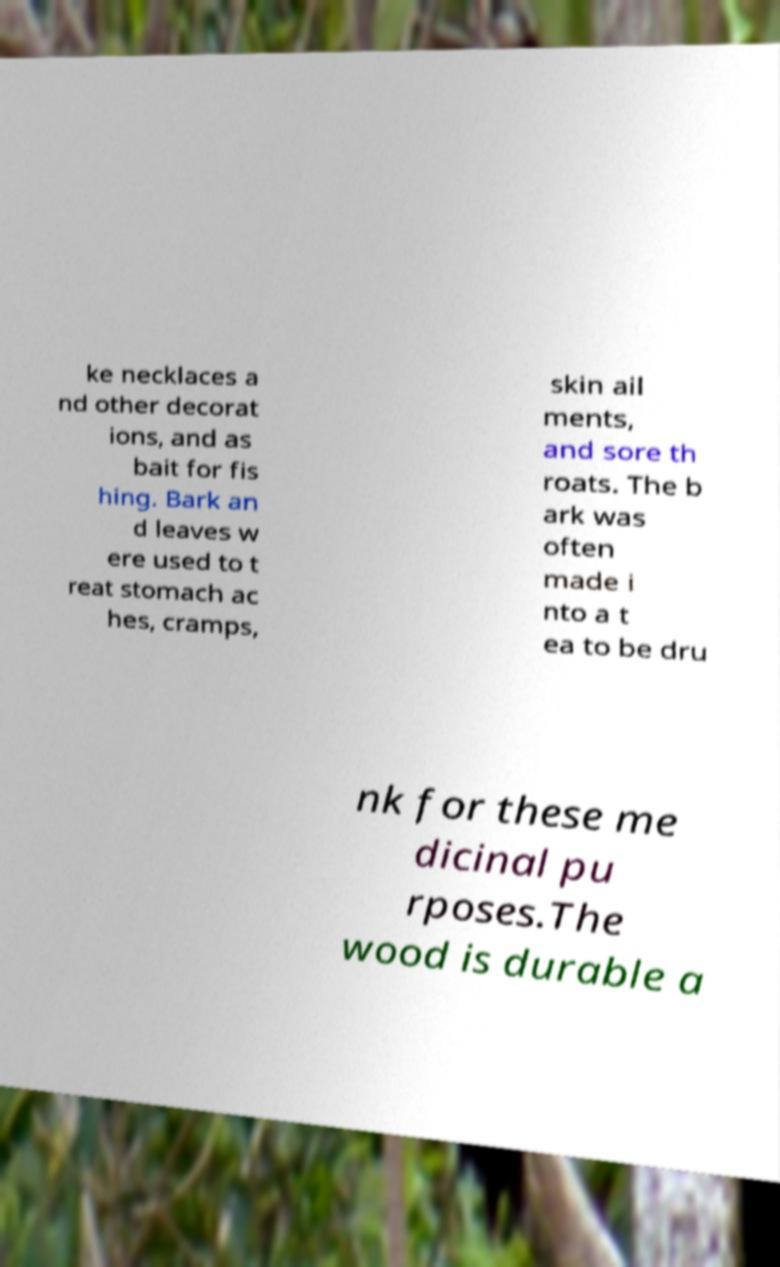Please identify and transcribe the text found in this image. ke necklaces a nd other decorat ions, and as bait for fis hing. Bark an d leaves w ere used to t reat stomach ac hes, cramps, skin ail ments, and sore th roats. The b ark was often made i nto a t ea to be dru nk for these me dicinal pu rposes.The wood is durable a 